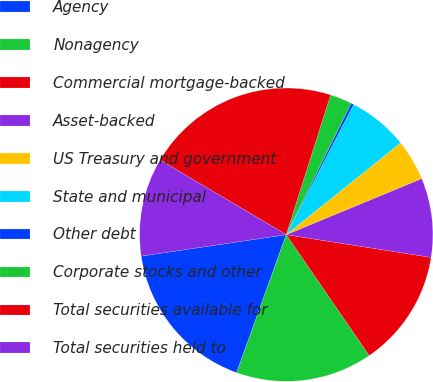Convert chart to OTSL. <chart><loc_0><loc_0><loc_500><loc_500><pie_chart><fcel>Agency<fcel>Nonagency<fcel>Commercial mortgage-backed<fcel>Asset-backed<fcel>US Treasury and government<fcel>State and municipal<fcel>Other debt<fcel>Corporate stocks and other<fcel>Total securities available for<fcel>Total securities held to<nl><fcel>17.17%<fcel>15.06%<fcel>12.95%<fcel>8.73%<fcel>4.52%<fcel>6.63%<fcel>0.3%<fcel>2.41%<fcel>21.39%<fcel>10.84%<nl></chart> 